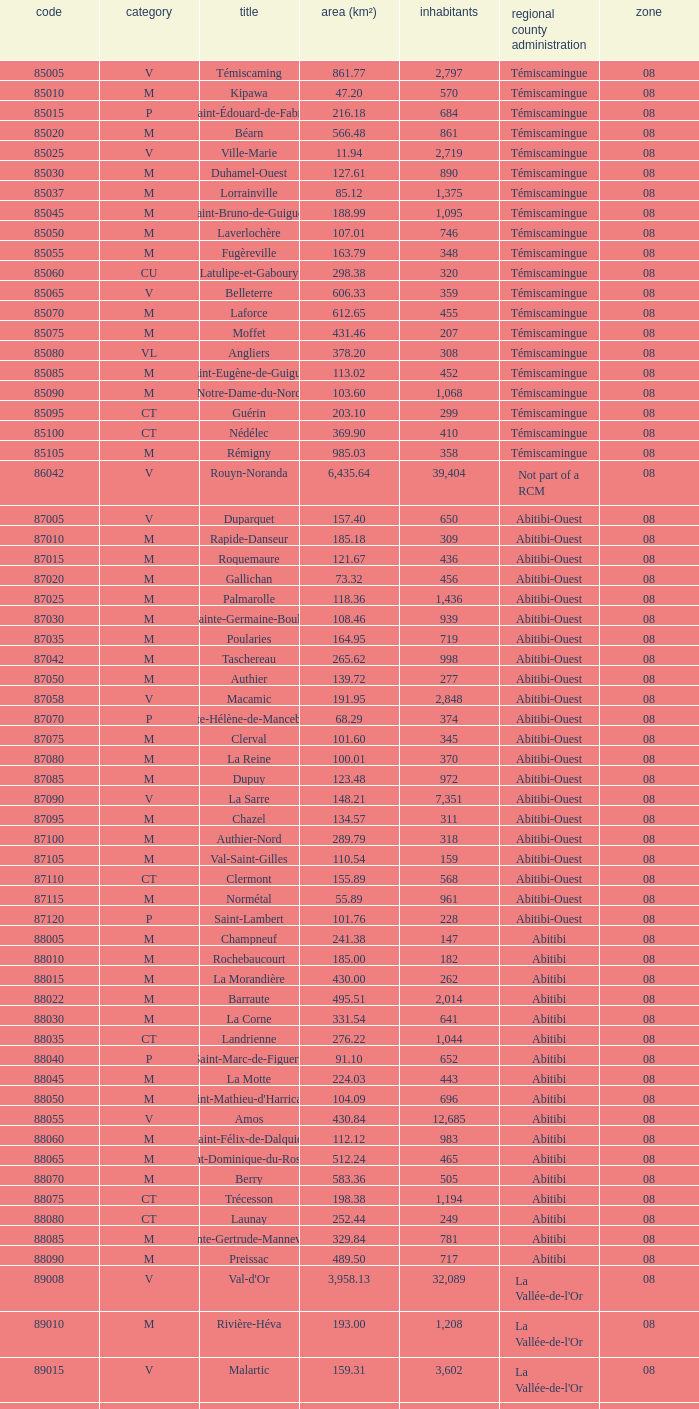I'm looking to parse the entire table for insights. Could you assist me with that? {'header': ['code', 'category', 'title', 'area (km²)', 'inhabitants', 'regional county administration', 'zone'], 'rows': [['85005', 'V', 'Témiscaming', '861.77', '2,797', 'Témiscamingue', '08'], ['85010', 'M', 'Kipawa', '47.20', '570', 'Témiscamingue', '08'], ['85015', 'P', 'Saint-Édouard-de-Fabre', '216.18', '684', 'Témiscamingue', '08'], ['85020', 'M', 'Béarn', '566.48', '861', 'Témiscamingue', '08'], ['85025', 'V', 'Ville-Marie', '11.94', '2,719', 'Témiscamingue', '08'], ['85030', 'M', 'Duhamel-Ouest', '127.61', '890', 'Témiscamingue', '08'], ['85037', 'M', 'Lorrainville', '85.12', '1,375', 'Témiscamingue', '08'], ['85045', 'M', 'Saint-Bruno-de-Guigues', '188.99', '1,095', 'Témiscamingue', '08'], ['85050', 'M', 'Laverlochère', '107.01', '746', 'Témiscamingue', '08'], ['85055', 'M', 'Fugèreville', '163.79', '348', 'Témiscamingue', '08'], ['85060', 'CU', 'Latulipe-et-Gaboury', '298.38', '320', 'Témiscamingue', '08'], ['85065', 'V', 'Belleterre', '606.33', '359', 'Témiscamingue', '08'], ['85070', 'M', 'Laforce', '612.65', '455', 'Témiscamingue', '08'], ['85075', 'M', 'Moffet', '431.46', '207', 'Témiscamingue', '08'], ['85080', 'VL', 'Angliers', '378.20', '308', 'Témiscamingue', '08'], ['85085', 'M', 'Saint-Eugène-de-Guigues', '113.02', '452', 'Témiscamingue', '08'], ['85090', 'M', 'Notre-Dame-du-Nord', '103.60', '1,068', 'Témiscamingue', '08'], ['85095', 'CT', 'Guérin', '203.10', '299', 'Témiscamingue', '08'], ['85100', 'CT', 'Nédélec', '369.90', '410', 'Témiscamingue', '08'], ['85105', 'M', 'Rémigny', '985.03', '358', 'Témiscamingue', '08'], ['86042', 'V', 'Rouyn-Noranda', '6,435.64', '39,404', 'Not part of a RCM', '08'], ['87005', 'V', 'Duparquet', '157.40', '650', 'Abitibi-Ouest', '08'], ['87010', 'M', 'Rapide-Danseur', '185.18', '309', 'Abitibi-Ouest', '08'], ['87015', 'M', 'Roquemaure', '121.67', '436', 'Abitibi-Ouest', '08'], ['87020', 'M', 'Gallichan', '73.32', '456', 'Abitibi-Ouest', '08'], ['87025', 'M', 'Palmarolle', '118.36', '1,436', 'Abitibi-Ouest', '08'], ['87030', 'M', 'Sainte-Germaine-Boulé', '108.46', '939', 'Abitibi-Ouest', '08'], ['87035', 'M', 'Poularies', '164.95', '719', 'Abitibi-Ouest', '08'], ['87042', 'M', 'Taschereau', '265.62', '998', 'Abitibi-Ouest', '08'], ['87050', 'M', 'Authier', '139.72', '277', 'Abitibi-Ouest', '08'], ['87058', 'V', 'Macamic', '191.95', '2,848', 'Abitibi-Ouest', '08'], ['87070', 'P', 'Sainte-Hélène-de-Mancebourg', '68.29', '374', 'Abitibi-Ouest', '08'], ['87075', 'M', 'Clerval', '101.60', '345', 'Abitibi-Ouest', '08'], ['87080', 'M', 'La Reine', '100.01', '370', 'Abitibi-Ouest', '08'], ['87085', 'M', 'Dupuy', '123.48', '972', 'Abitibi-Ouest', '08'], ['87090', 'V', 'La Sarre', '148.21', '7,351', 'Abitibi-Ouest', '08'], ['87095', 'M', 'Chazel', '134.57', '311', 'Abitibi-Ouest', '08'], ['87100', 'M', 'Authier-Nord', '289.79', '318', 'Abitibi-Ouest', '08'], ['87105', 'M', 'Val-Saint-Gilles', '110.54', '159', 'Abitibi-Ouest', '08'], ['87110', 'CT', 'Clermont', '155.89', '568', 'Abitibi-Ouest', '08'], ['87115', 'M', 'Normétal', '55.89', '961', 'Abitibi-Ouest', '08'], ['87120', 'P', 'Saint-Lambert', '101.76', '228', 'Abitibi-Ouest', '08'], ['88005', 'M', 'Champneuf', '241.38', '147', 'Abitibi', '08'], ['88010', 'M', 'Rochebaucourt', '185.00', '182', 'Abitibi', '08'], ['88015', 'M', 'La Morandière', '430.00', '262', 'Abitibi', '08'], ['88022', 'M', 'Barraute', '495.51', '2,014', 'Abitibi', '08'], ['88030', 'M', 'La Corne', '331.54', '641', 'Abitibi', '08'], ['88035', 'CT', 'Landrienne', '276.22', '1,044', 'Abitibi', '08'], ['88040', 'P', 'Saint-Marc-de-Figuery', '91.10', '652', 'Abitibi', '08'], ['88045', 'M', 'La Motte', '224.03', '443', 'Abitibi', '08'], ['88050', 'M', "Saint-Mathieu-d'Harricana", '104.09', '696', 'Abitibi', '08'], ['88055', 'V', 'Amos', '430.84', '12,685', 'Abitibi', '08'], ['88060', 'M', 'Saint-Félix-de-Dalquier', '112.12', '983', 'Abitibi', '08'], ['88065', 'M', 'Saint-Dominique-du-Rosaire', '512.24', '465', 'Abitibi', '08'], ['88070', 'M', 'Berry', '583.36', '505', 'Abitibi', '08'], ['88075', 'CT', 'Trécesson', '198.38', '1,194', 'Abitibi', '08'], ['88080', 'CT', 'Launay', '252.44', '249', 'Abitibi', '08'], ['88085', 'M', 'Sainte-Gertrude-Manneville', '329.84', '781', 'Abitibi', '08'], ['88090', 'M', 'Preissac', '489.50', '717', 'Abitibi', '08'], ['89008', 'V', "Val-d'Or", '3,958.13', '32,089', "La Vallée-de-l'Or", '08'], ['89010', 'M', 'Rivière-Héva', '193.00', '1,208', "La Vallée-de-l'Or", '08'], ['89015', 'V', 'Malartic', '159.31', '3,602', "La Vallée-de-l'Or", '08'], ['89040', 'V', 'Senneterre', '16,524.89', '3,165', "La Vallée-de-l'Or", '08'], ['89045', 'P', 'Senneterre', '432.98', '1,146', "La Vallée-de-l'Or", '08'], ['89050', 'M', 'Belcourt', '411.23', '261', "La Vallée-de-l'Or", '08']]} What is Dupuy lowest area in km2? 123.48. 